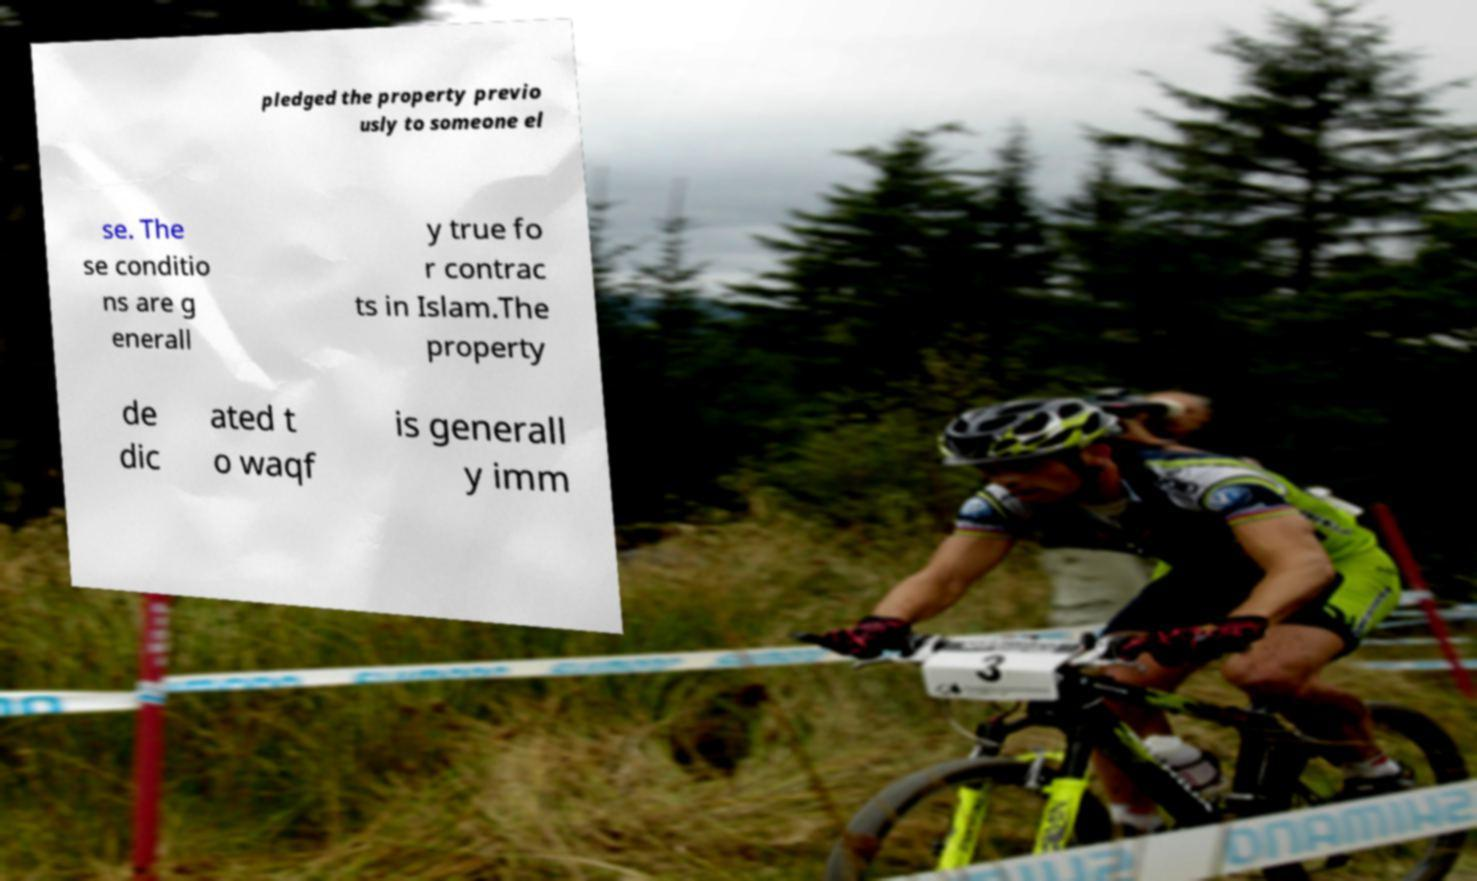Could you assist in decoding the text presented in this image and type it out clearly? pledged the property previo usly to someone el se. The se conditio ns are g enerall y true fo r contrac ts in Islam.The property de dic ated t o waqf is generall y imm 